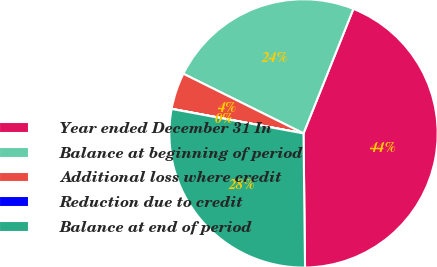Convert chart. <chart><loc_0><loc_0><loc_500><loc_500><pie_chart><fcel>Year ended December 31 In<fcel>Balance at beginning of period<fcel>Additional loss where credit<fcel>Reduction due to credit<fcel>Balance at end of period<nl><fcel>43.76%<fcel>23.73%<fcel>4.4%<fcel>0.02%<fcel>28.1%<nl></chart> 